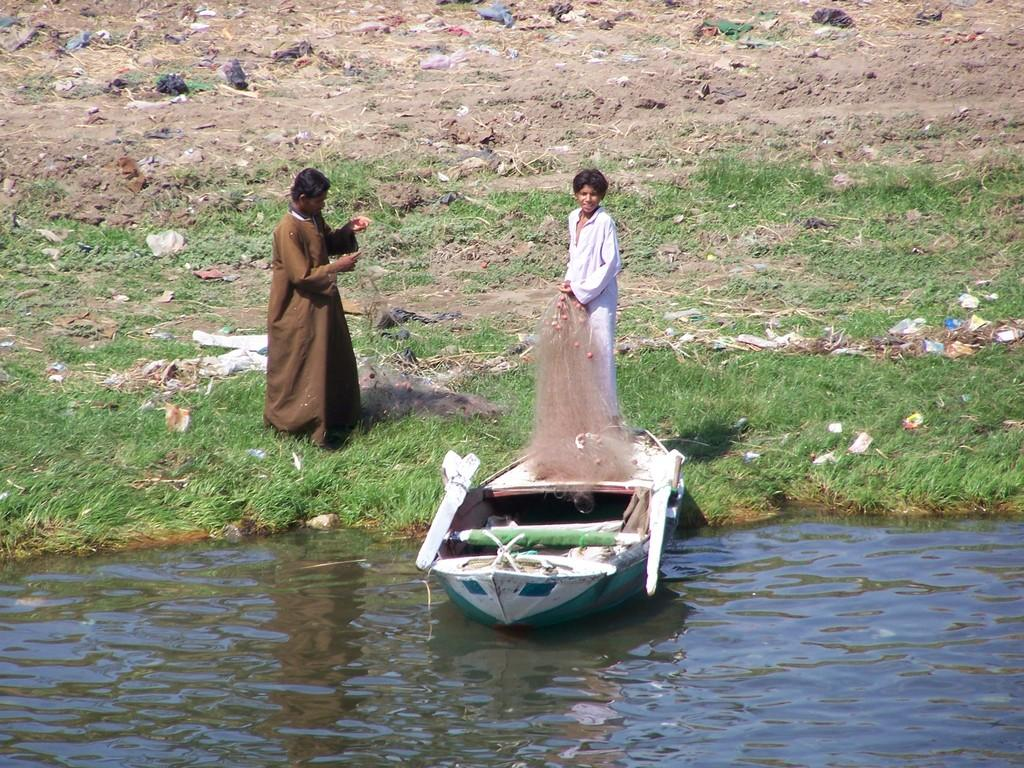What is in the water in the image? There is a boat in the water in the image. Where are the two people located in the image? The two people are on the green grass in the image. What can be seen near the boat in the water? There is a fishing net visible in the image. Where is the faucet located in the image? There is no faucet present in the image. What type of friction can be observed between the boat and the water in the image? The image does not provide information about the friction between the boat and the water. 